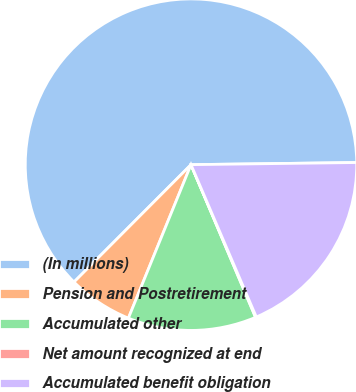<chart> <loc_0><loc_0><loc_500><loc_500><pie_chart><fcel>(In millions)<fcel>Pension and Postretirement<fcel>Accumulated other<fcel>Net amount recognized at end<fcel>Accumulated benefit obligation<nl><fcel>62.32%<fcel>6.31%<fcel>12.53%<fcel>0.08%<fcel>18.76%<nl></chart> 